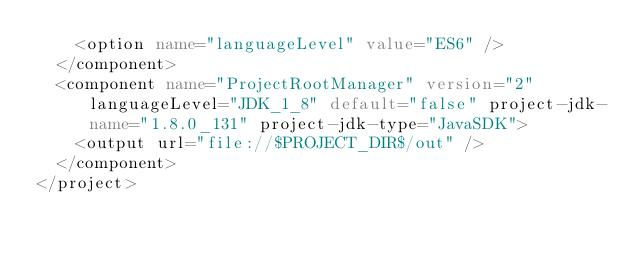<code> <loc_0><loc_0><loc_500><loc_500><_XML_>    <option name="languageLevel" value="ES6" />
  </component>
  <component name="ProjectRootManager" version="2" languageLevel="JDK_1_8" default="false" project-jdk-name="1.8.0_131" project-jdk-type="JavaSDK">
    <output url="file://$PROJECT_DIR$/out" />
  </component>
</project></code> 